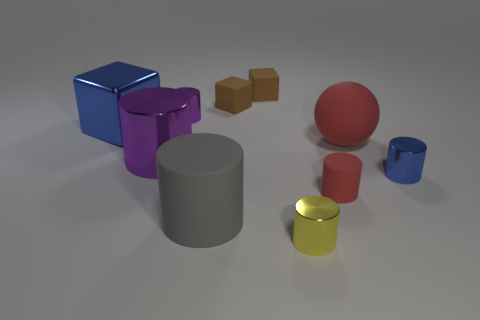Subtract all green balls. How many brown cubes are left? 2 Subtract all small brown matte cubes. How many cubes are left? 1 Subtract all yellow cylinders. How many cylinders are left? 5 Subtract 2 cylinders. How many cylinders are left? 4 Subtract all balls. How many objects are left? 9 Subtract all red cylinders. Subtract all small green matte cubes. How many objects are left? 9 Add 6 matte cylinders. How many matte cylinders are left? 8 Add 2 small yellow metallic cylinders. How many small yellow metallic cylinders exist? 3 Subtract 0 cyan balls. How many objects are left? 10 Subtract all brown cylinders. Subtract all purple blocks. How many cylinders are left? 6 